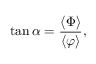<formula> <loc_0><loc_0><loc_500><loc_500>\tan \alpha = \frac { \langle \Phi \rangle } { \langle \varphi \rangle } ,</formula> 